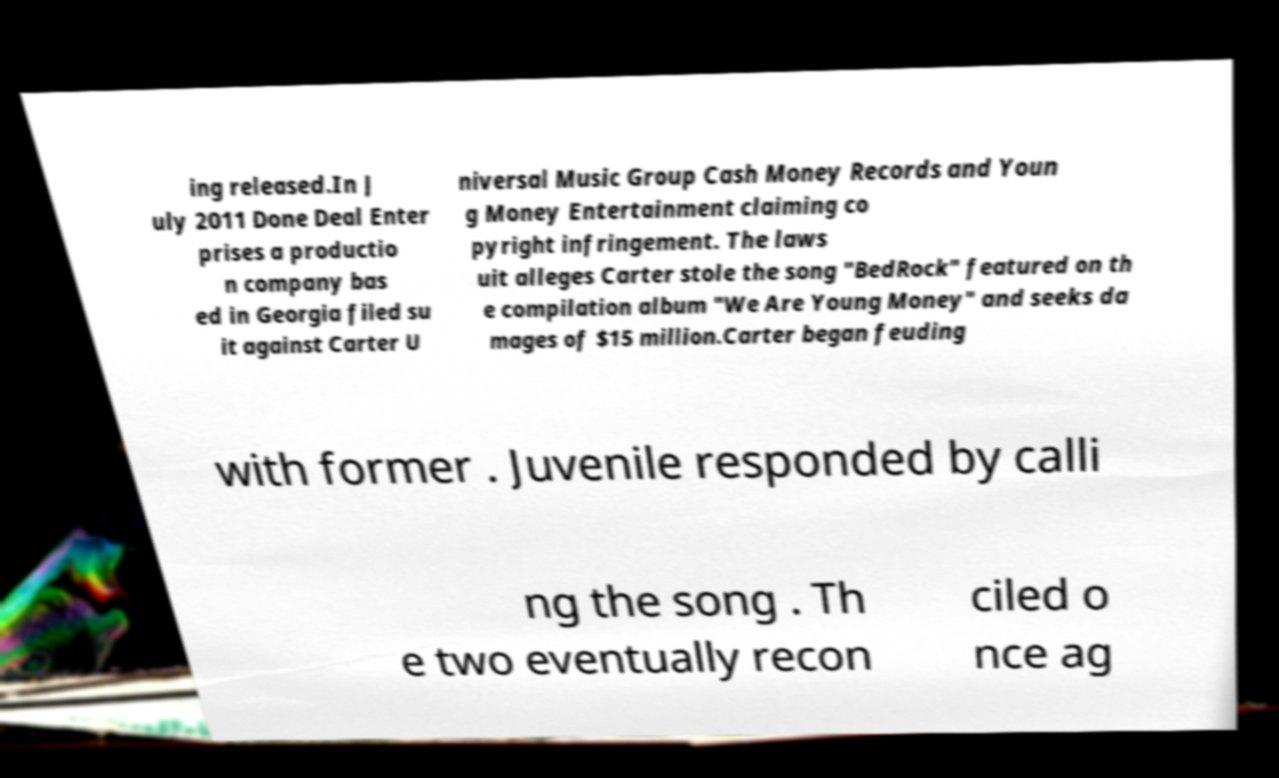Could you assist in decoding the text presented in this image and type it out clearly? ing released.In J uly 2011 Done Deal Enter prises a productio n company bas ed in Georgia filed su it against Carter U niversal Music Group Cash Money Records and Youn g Money Entertainment claiming co pyright infringement. The laws uit alleges Carter stole the song "BedRock" featured on th e compilation album "We Are Young Money" and seeks da mages of $15 million.Carter began feuding with former . Juvenile responded by calli ng the song . Th e two eventually recon ciled o nce ag 